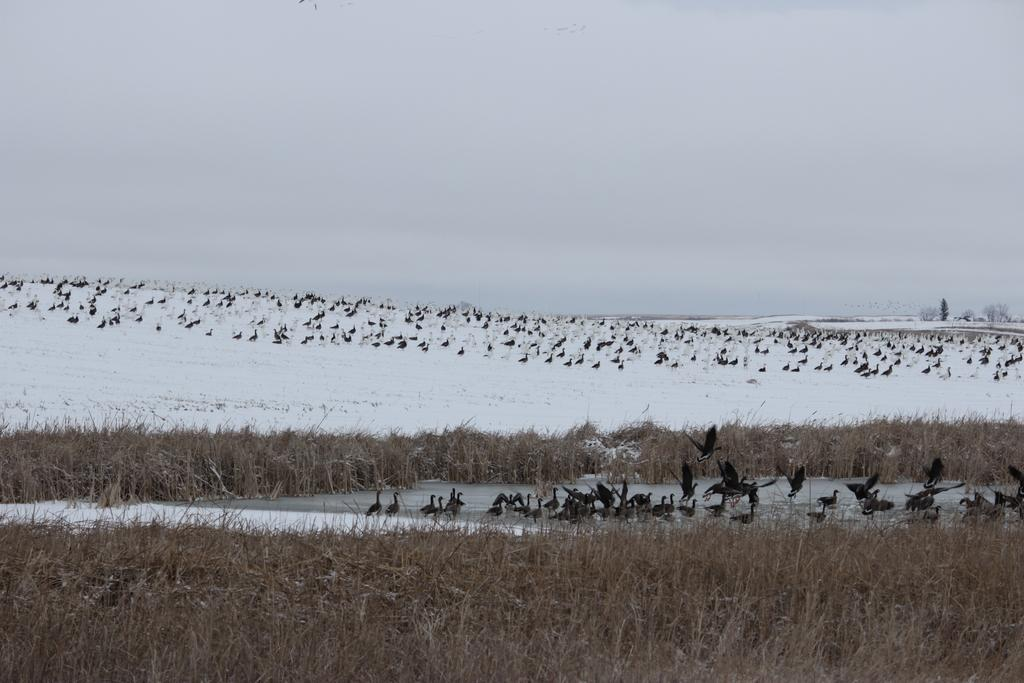What type of animals can be seen in the image? There are birds in the image. What is located at the bottom of the image? There is grass at the bottom of the image. What is the weather like in the image? There is snow visible in the image, which suggests a cold or wintry environment. What can be seen in the background of the image? There is sky and trees in the background of the image. What type of existence do the birds have in the image? The question is not definitively answerable from the image, as it focuses on the existence of the birds rather than their observable characteristics or location. 